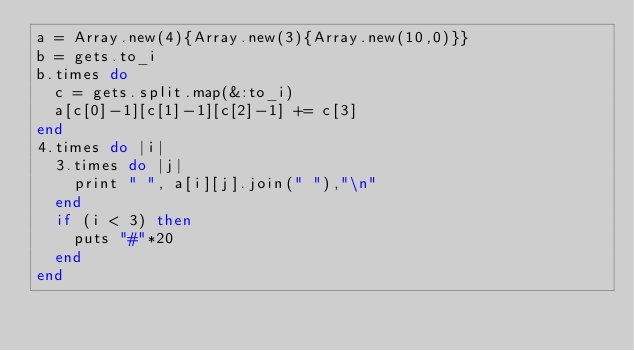<code> <loc_0><loc_0><loc_500><loc_500><_Ruby_>a = Array.new(4){Array.new(3){Array.new(10,0)}}
b = gets.to_i
b.times do
  c = gets.split.map(&:to_i)
  a[c[0]-1][c[1]-1][c[2]-1] += c[3]
end
4.times do |i|
  3.times do |j|
    print " ", a[i][j].join(" "),"\n"
  end
  if (i < 3) then
    puts "#"*20
  end
end</code> 